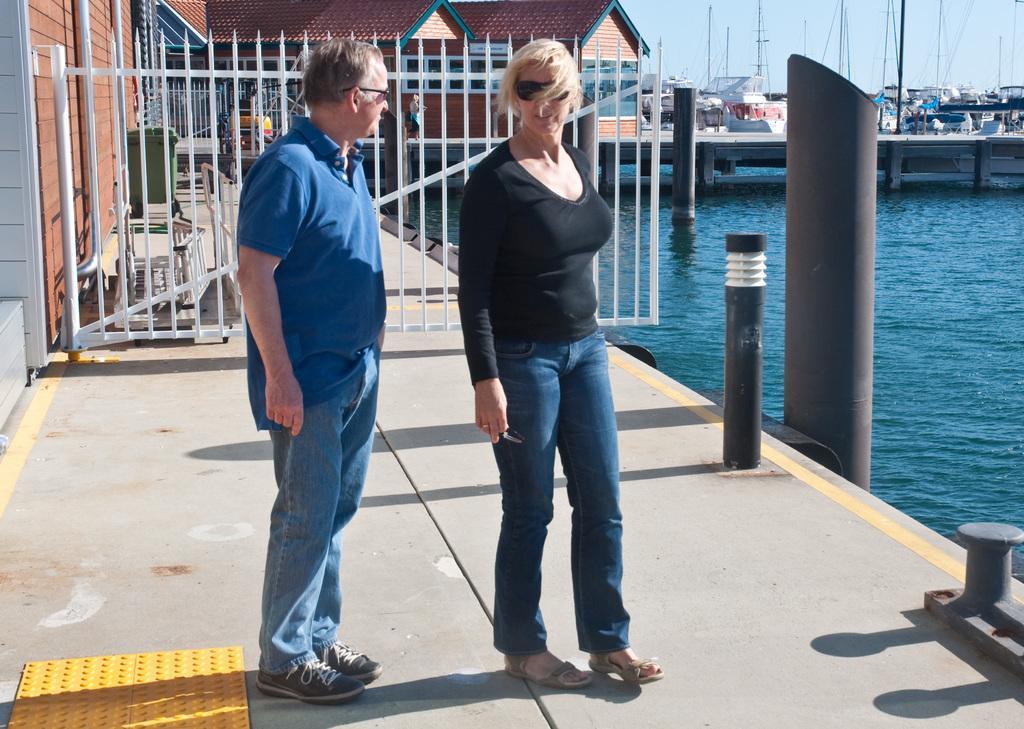How would you summarize this image in a sentence or two? In this image, we can see a man and a woman standing on the left side, we can see some homes and we can see the metal fence, on the right side, we can see water, at the top we can see the sky. 